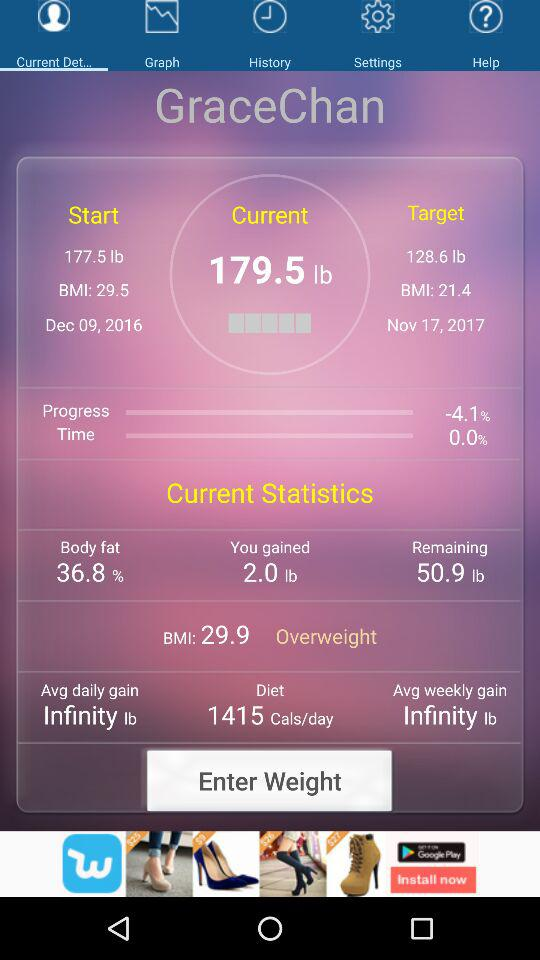What is the current weight? The current weight is 179.5 lb. 